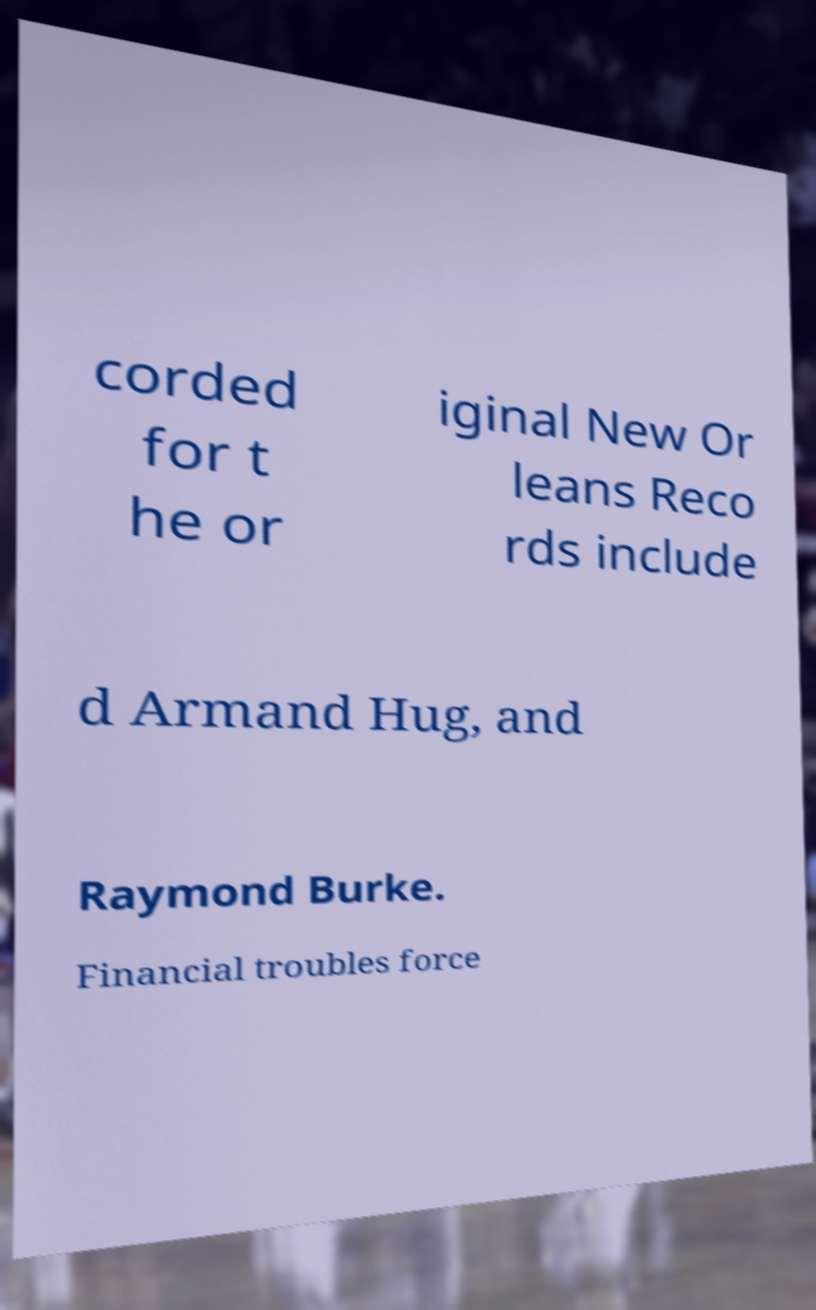What messages or text are displayed in this image? I need them in a readable, typed format. corded for t he or iginal New Or leans Reco rds include d Armand Hug, and Raymond Burke. Financial troubles force 